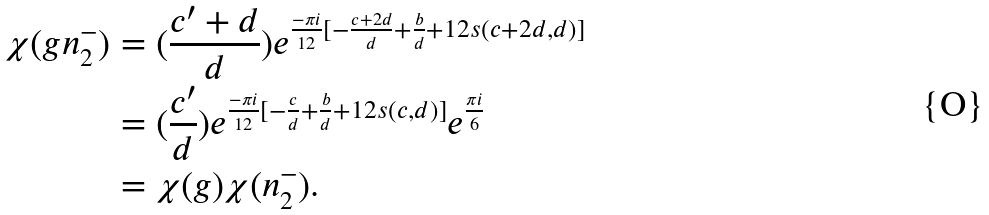Convert formula to latex. <formula><loc_0><loc_0><loc_500><loc_500>\chi ( g n _ { 2 } ^ { - } ) & = ( \frac { c ^ { \prime } + d } { d } ) e ^ { \frac { - \pi i } { 1 2 } [ - \frac { c + 2 d } { d } + \frac { b } { d } + 1 2 s ( c + 2 d , d ) ] } \\ & = ( \frac { c ^ { \prime } } { d } ) e ^ { \frac { - \pi i } { 1 2 } [ - \frac { c } { d } + \frac { b } { d } + 1 2 s ( c , d ) ] } e ^ { \frac { \pi i } { 6 } } \\ & = \chi ( g ) \chi ( n _ { 2 } ^ { - } ) .</formula> 